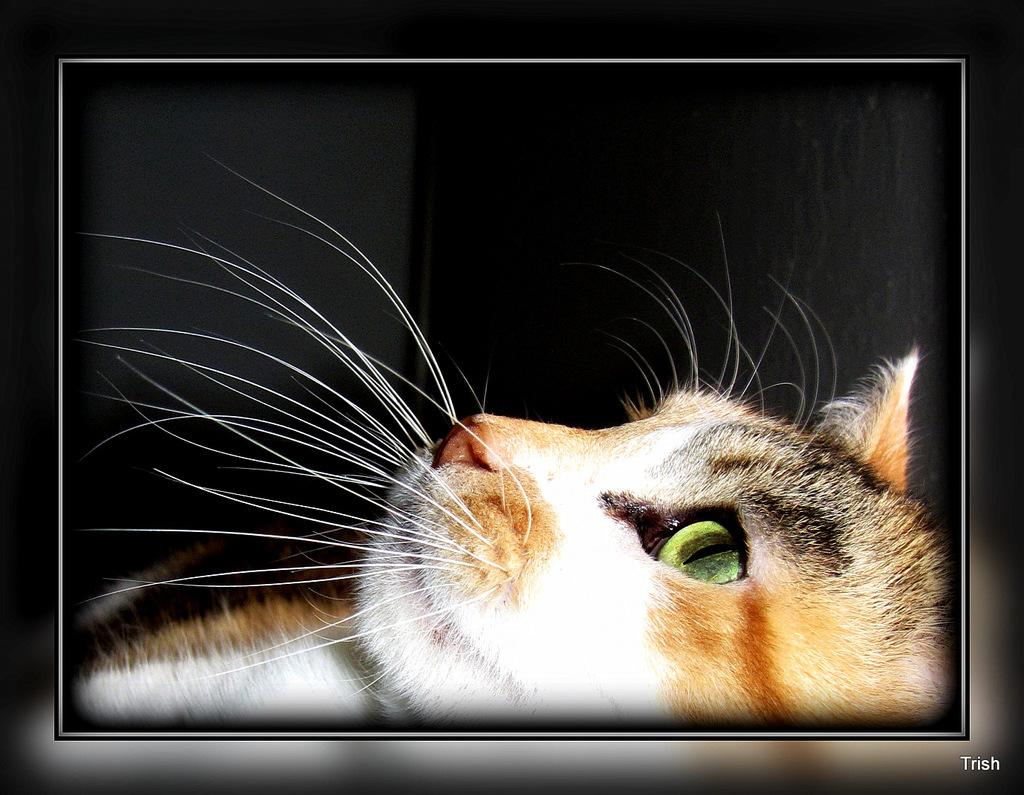What type of animal is in the image? The animal in the image has not been specified, but it has white, brown, and black coloring and whiskers. What colors can be seen on the animal in the image? The animal in the image has white, brown, and black coloring. What feature is present on the animal's face? The animal in the image has whiskers. What color is the background of the image? The background of the image is black. What type of crime is being committed in the image? There is no indication of a crime being committed in the image; it features an animal with specific coloring and facial features against a black background. Can you hear the bell ringing in the image? There is no bell present in the image, so it cannot be heard. 